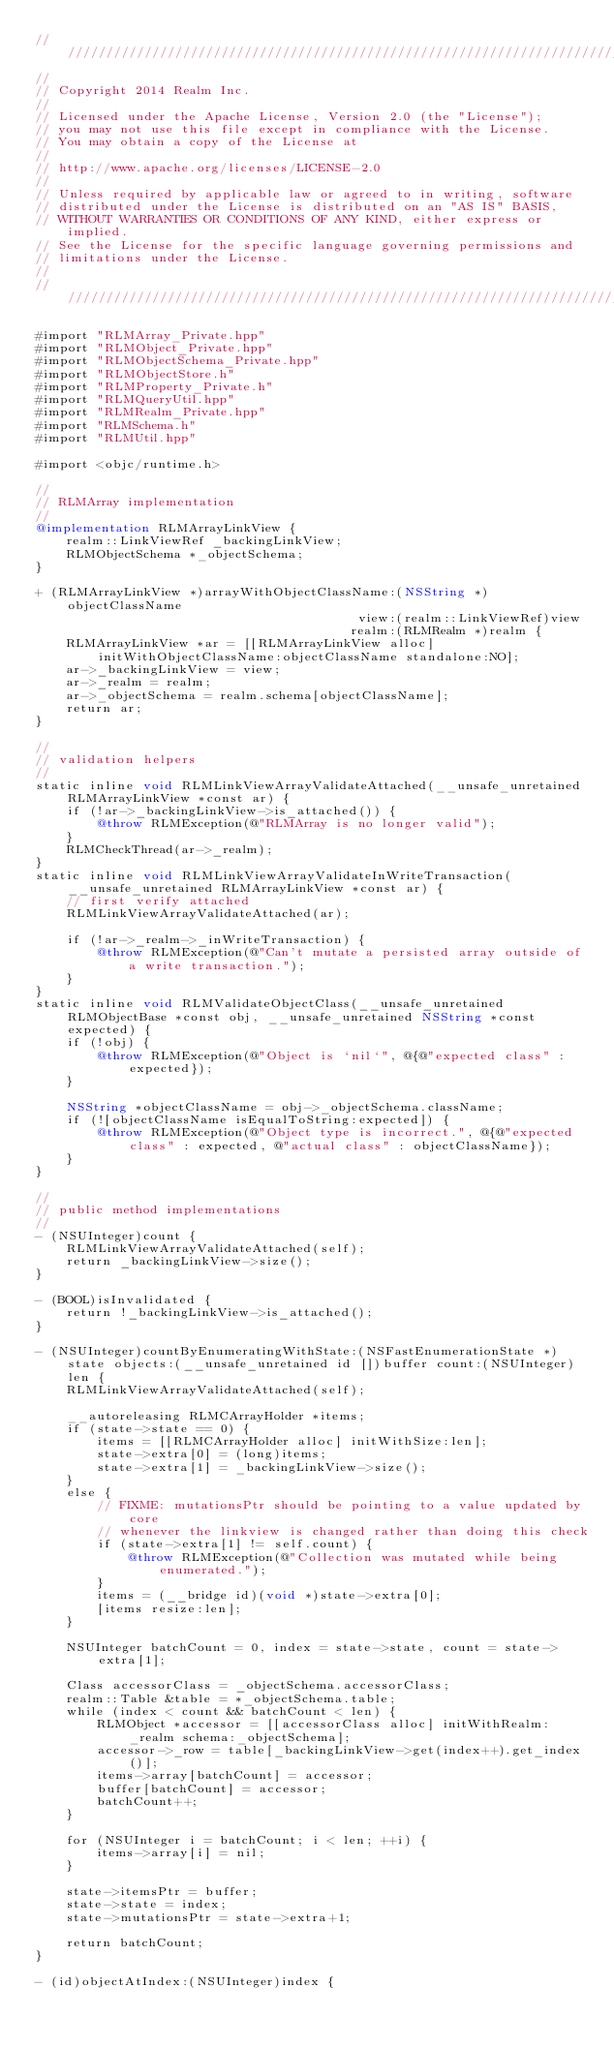<code> <loc_0><loc_0><loc_500><loc_500><_ObjectiveC_>////////////////////////////////////////////////////////////////////////////
//
// Copyright 2014 Realm Inc.
//
// Licensed under the Apache License, Version 2.0 (the "License");
// you may not use this file except in compliance with the License.
// You may obtain a copy of the License at
//
// http://www.apache.org/licenses/LICENSE-2.0
//
// Unless required by applicable law or agreed to in writing, software
// distributed under the License is distributed on an "AS IS" BASIS,
// WITHOUT WARRANTIES OR CONDITIONS OF ANY KIND, either express or implied.
// See the License for the specific language governing permissions and
// limitations under the License.
//
////////////////////////////////////////////////////////////////////////////

#import "RLMArray_Private.hpp"
#import "RLMObject_Private.hpp"
#import "RLMObjectSchema_Private.hpp"
#import "RLMObjectStore.h"
#import "RLMProperty_Private.h"
#import "RLMQueryUtil.hpp"
#import "RLMRealm_Private.hpp"
#import "RLMSchema.h"
#import "RLMUtil.hpp"

#import <objc/runtime.h>

//
// RLMArray implementation
//
@implementation RLMArrayLinkView {
    realm::LinkViewRef _backingLinkView;
    RLMObjectSchema *_objectSchema;
}

+ (RLMArrayLinkView *)arrayWithObjectClassName:(NSString *)objectClassName
                                          view:(realm::LinkViewRef)view
                                         realm:(RLMRealm *)realm {
    RLMArrayLinkView *ar = [[RLMArrayLinkView alloc] initWithObjectClassName:objectClassName standalone:NO];
    ar->_backingLinkView = view;
    ar->_realm = realm;
    ar->_objectSchema = realm.schema[objectClassName];
    return ar;
}

//
// validation helpers
//
static inline void RLMLinkViewArrayValidateAttached(__unsafe_unretained RLMArrayLinkView *const ar) {
    if (!ar->_backingLinkView->is_attached()) {
        @throw RLMException(@"RLMArray is no longer valid");
    }
    RLMCheckThread(ar->_realm);
}
static inline void RLMLinkViewArrayValidateInWriteTransaction(__unsafe_unretained RLMArrayLinkView *const ar) {
    // first verify attached
    RLMLinkViewArrayValidateAttached(ar);

    if (!ar->_realm->_inWriteTransaction) {
        @throw RLMException(@"Can't mutate a persisted array outside of a write transaction.");
    }
}
static inline void RLMValidateObjectClass(__unsafe_unretained RLMObjectBase *const obj, __unsafe_unretained NSString *const expected) {
    if (!obj) {
        @throw RLMException(@"Object is `nil`", @{@"expected class" : expected});
    }

    NSString *objectClassName = obj->_objectSchema.className;
    if (![objectClassName isEqualToString:expected]) {
        @throw RLMException(@"Object type is incorrect.", @{@"expected class" : expected, @"actual class" : objectClassName});
    }
}

//
// public method implementations
//
- (NSUInteger)count {
    RLMLinkViewArrayValidateAttached(self);
    return _backingLinkView->size();
}

- (BOOL)isInvalidated {
    return !_backingLinkView->is_attached();
}

- (NSUInteger)countByEnumeratingWithState:(NSFastEnumerationState *)state objects:(__unsafe_unretained id [])buffer count:(NSUInteger)len {
    RLMLinkViewArrayValidateAttached(self);

    __autoreleasing RLMCArrayHolder *items;
    if (state->state == 0) {
        items = [[RLMCArrayHolder alloc] initWithSize:len];
        state->extra[0] = (long)items;
        state->extra[1] = _backingLinkView->size();
    }
    else {
        // FIXME: mutationsPtr should be pointing to a value updated by core
        // whenever the linkview is changed rather than doing this check
        if (state->extra[1] != self.count) {
            @throw RLMException(@"Collection was mutated while being enumerated.");
        }
        items = (__bridge id)(void *)state->extra[0];
        [items resize:len];
    }

    NSUInteger batchCount = 0, index = state->state, count = state->extra[1];

    Class accessorClass = _objectSchema.accessorClass;
    realm::Table &table = *_objectSchema.table;
    while (index < count && batchCount < len) {
        RLMObject *accessor = [[accessorClass alloc] initWithRealm:_realm schema:_objectSchema];
        accessor->_row = table[_backingLinkView->get(index++).get_index()];
        items->array[batchCount] = accessor;
        buffer[batchCount] = accessor;
        batchCount++;
    }

    for (NSUInteger i = batchCount; i < len; ++i) {
        items->array[i] = nil;
    }

    state->itemsPtr = buffer;
    state->state = index;
    state->mutationsPtr = state->extra+1;

    return batchCount;
}

- (id)objectAtIndex:(NSUInteger)index {</code> 